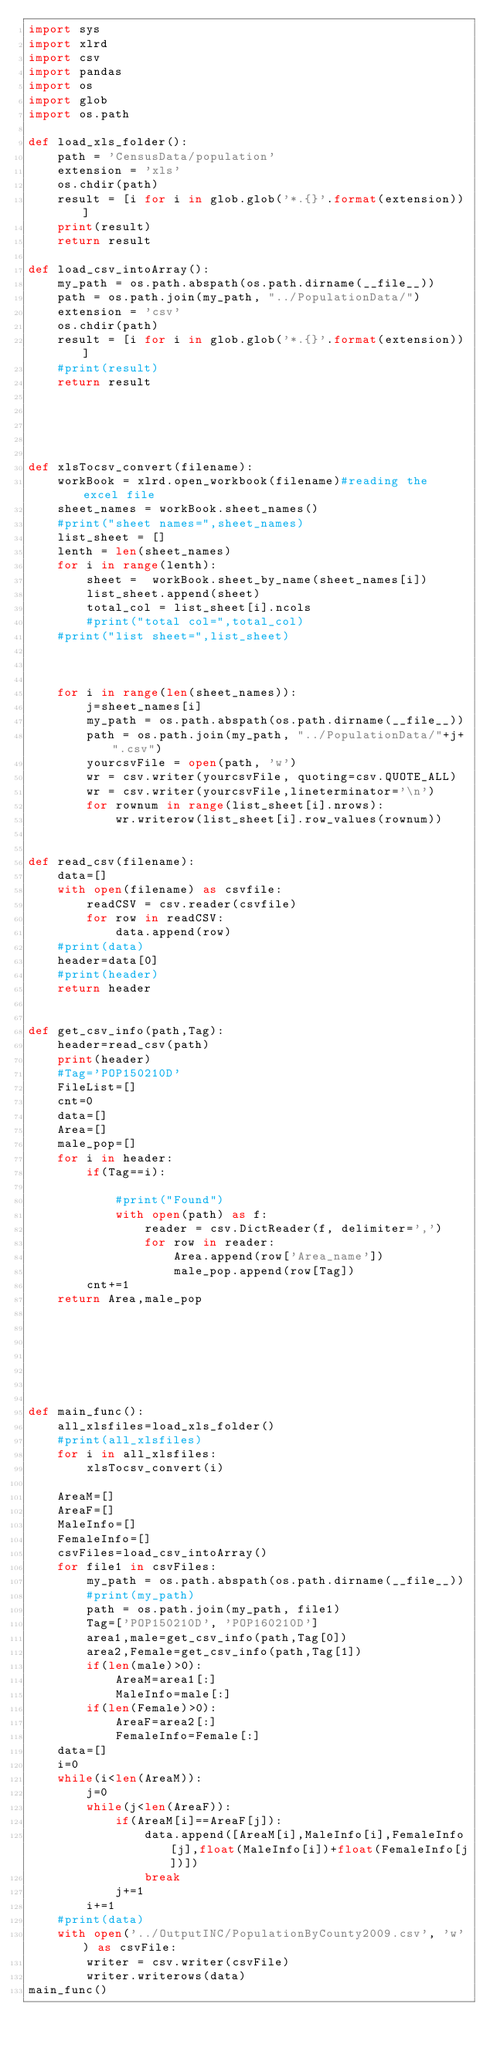Convert code to text. <code><loc_0><loc_0><loc_500><loc_500><_Python_>import sys
import xlrd
import csv
import pandas
import os
import glob
import os.path

def load_xls_folder():
    path = 'CensusData/population'
    extension = 'xls'
    os.chdir(path)
    result = [i for i in glob.glob('*.{}'.format(extension))]
    print(result)
    return result    

def load_csv_intoArray():
	my_path = os.path.abspath(os.path.dirname(__file__))
	path = os.path.join(my_path, "../PopulationData/")
	extension = 'csv'
	os.chdir(path)
	result = [i for i in glob.glob('*.{}'.format(extension))]
	#print(result)
	return result    
        
    
            
    
    
def xlsTocsv_convert(filename):
    workBook = xlrd.open_workbook(filename)#reading the excel file
    sheet_names = workBook.sheet_names()
    #print("sheet names=",sheet_names)
    list_sheet = []
    lenth = len(sheet_names)
    for i in range(lenth):
        sheet =  workBook.sheet_by_name(sheet_names[i])
        list_sheet.append(sheet)
        total_col = list_sheet[i].ncols
        #print("total col=",total_col)
    #print("list sheet=",list_sheet)   
    
    
    
    for i in range(len(sheet_names)):
        j=sheet_names[i]
        my_path = os.path.abspath(os.path.dirname(__file__))
        path = os.path.join(my_path, "../PopulationData/"+j+".csv")
        yourcsvFile = open(path, 'w')
        wr = csv.writer(yourcsvFile, quoting=csv.QUOTE_ALL)
        wr = csv.writer(yourcsvFile,lineterminator='\n')
        for rownum in range(list_sheet[i].nrows):
            wr.writerow(list_sheet[i].row_values(rownum))
               

def read_csv(filename):
    data=[]
    with open(filename) as csvfile:
        readCSV = csv.reader(csvfile)
        for row in readCSV:
            data.append(row)
    #print(data)
    header=data[0]   
    #print(header) 
    return header


def get_csv_info(path,Tag):
	header=read_csv(path)
	print(header)
	#Tag='POP150210D'
	FileList=[]
	cnt=0
	data=[]
	Area=[]
	male_pop=[]
	for i in header:
		if(Tag==i):
			
			#print("Found")
			with open(path) as f:
				reader = csv.DictReader(f, delimiter=',')
				for row in reader:
					Area.append(row['Area_name'])
					male_pop.append(row[Tag])
		cnt+=1
	return Area,male_pop
		
		

		
		
		

def main_func():
    all_xlsfiles=load_xls_folder()
    #print(all_xlsfiles)
    for i in all_xlsfiles:
        xlsTocsv_convert(i)
    
    AreaM=[]
    AreaF=[]
    MaleInfo=[]
    FemaleInfo=[]
    csvFiles=load_csv_intoArray()
    for file1 in csvFiles:
    	my_path = os.path.abspath(os.path.dirname(__file__))
    	#print(my_path)
    	path = os.path.join(my_path, file1)
    	Tag=['POP150210D', 'POP160210D']
    	area1,male=get_csv_info(path,Tag[0])
    	area2,Female=get_csv_info(path,Tag[1])
    	if(len(male)>0):
    		AreaM=area1[:]
    		MaleInfo=male[:]
    	if(len(Female)>0):
    		AreaF=area2[:]
    		FemaleInfo=Female[:]
    data=[]
    i=0
    while(i<len(AreaM)):
    	j=0
    	while(j<len(AreaF)):
    		if(AreaM[i]==AreaF[j]):
    			data.append([AreaM[i],MaleInfo[i],FemaleInfo[j],float(MaleInfo[i])+float(FemaleInfo[j])])
    			break
    		j+=1
    	i+=1
    #print(data)
    with open('../OutputINC/PopulationByCounty2009.csv', 'w') as csvFile:
    	writer = csv.writer(csvFile)
    	writer.writerows(data)
main_func()</code> 